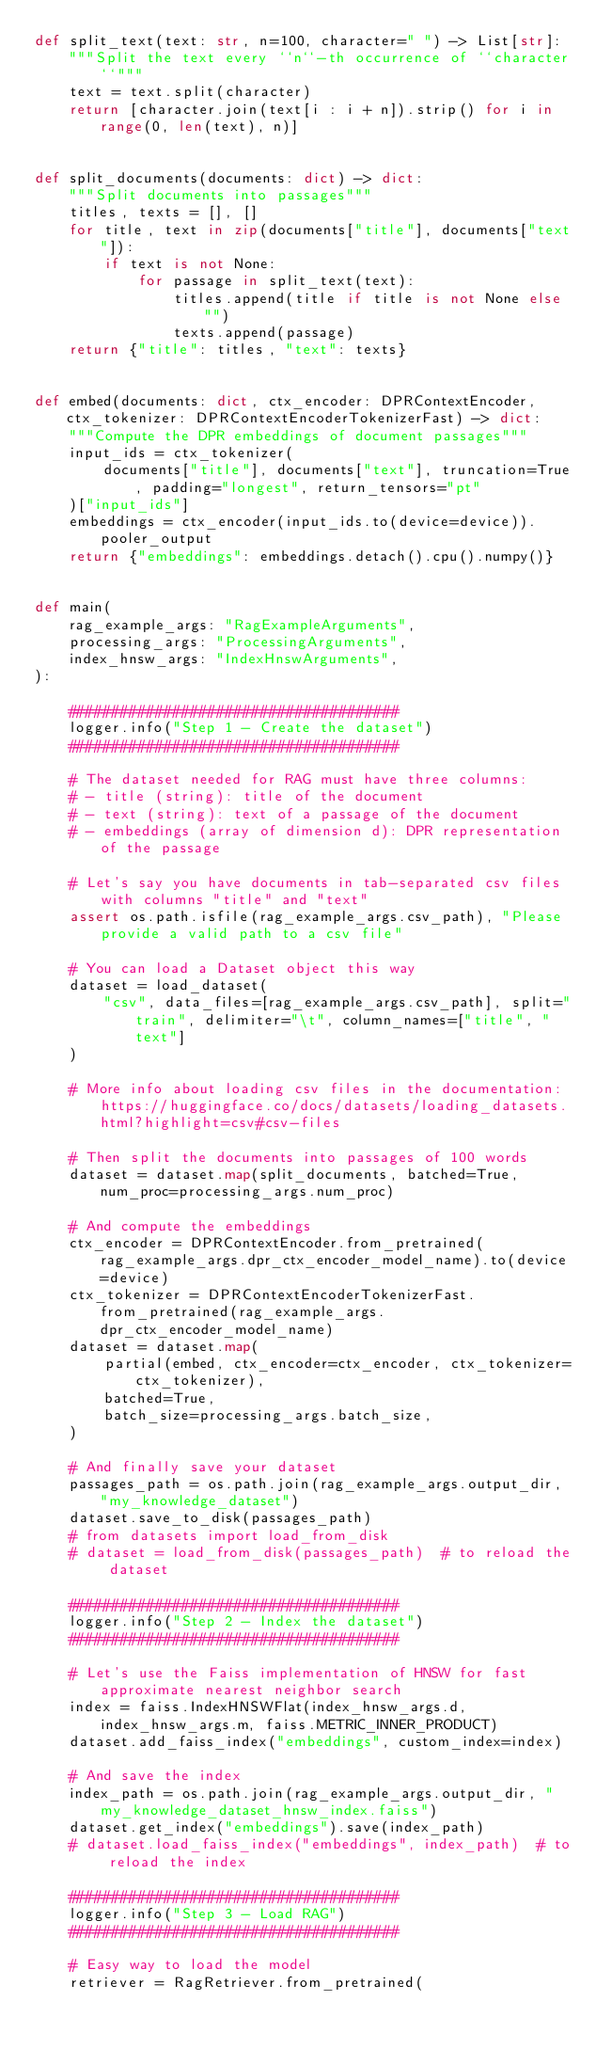<code> <loc_0><loc_0><loc_500><loc_500><_Python_>def split_text(text: str, n=100, character=" ") -> List[str]:
    """Split the text every ``n``-th occurrence of ``character``"""
    text = text.split(character)
    return [character.join(text[i : i + n]).strip() for i in range(0, len(text), n)]


def split_documents(documents: dict) -> dict:
    """Split documents into passages"""
    titles, texts = [], []
    for title, text in zip(documents["title"], documents["text"]):
        if text is not None:
            for passage in split_text(text):
                titles.append(title if title is not None else "")
                texts.append(passage)
    return {"title": titles, "text": texts}


def embed(documents: dict, ctx_encoder: DPRContextEncoder, ctx_tokenizer: DPRContextEncoderTokenizerFast) -> dict:
    """Compute the DPR embeddings of document passages"""
    input_ids = ctx_tokenizer(
        documents["title"], documents["text"], truncation=True, padding="longest", return_tensors="pt"
    )["input_ids"]
    embeddings = ctx_encoder(input_ids.to(device=device)).pooler_output
    return {"embeddings": embeddings.detach().cpu().numpy()}


def main(
    rag_example_args: "RagExampleArguments",
    processing_args: "ProcessingArguments",
    index_hnsw_args: "IndexHnswArguments",
):

    ######################################
    logger.info("Step 1 - Create the dataset")
    ######################################

    # The dataset needed for RAG must have three columns:
    # - title (string): title of the document
    # - text (string): text of a passage of the document
    # - embeddings (array of dimension d): DPR representation of the passage

    # Let's say you have documents in tab-separated csv files with columns "title" and "text"
    assert os.path.isfile(rag_example_args.csv_path), "Please provide a valid path to a csv file"

    # You can load a Dataset object this way
    dataset = load_dataset(
        "csv", data_files=[rag_example_args.csv_path], split="train", delimiter="\t", column_names=["title", "text"]
    )

    # More info about loading csv files in the documentation: https://huggingface.co/docs/datasets/loading_datasets.html?highlight=csv#csv-files

    # Then split the documents into passages of 100 words
    dataset = dataset.map(split_documents, batched=True, num_proc=processing_args.num_proc)

    # And compute the embeddings
    ctx_encoder = DPRContextEncoder.from_pretrained(rag_example_args.dpr_ctx_encoder_model_name).to(device=device)
    ctx_tokenizer = DPRContextEncoderTokenizerFast.from_pretrained(rag_example_args.dpr_ctx_encoder_model_name)
    dataset = dataset.map(
        partial(embed, ctx_encoder=ctx_encoder, ctx_tokenizer=ctx_tokenizer),
        batched=True,
        batch_size=processing_args.batch_size,
    )

    # And finally save your dataset
    passages_path = os.path.join(rag_example_args.output_dir, "my_knowledge_dataset")
    dataset.save_to_disk(passages_path)
    # from datasets import load_from_disk
    # dataset = load_from_disk(passages_path)  # to reload the dataset

    ######################################
    logger.info("Step 2 - Index the dataset")
    ######################################

    # Let's use the Faiss implementation of HNSW for fast approximate nearest neighbor search
    index = faiss.IndexHNSWFlat(index_hnsw_args.d, index_hnsw_args.m, faiss.METRIC_INNER_PRODUCT)
    dataset.add_faiss_index("embeddings", custom_index=index)

    # And save the index
    index_path = os.path.join(rag_example_args.output_dir, "my_knowledge_dataset_hnsw_index.faiss")
    dataset.get_index("embeddings").save(index_path)
    # dataset.load_faiss_index("embeddings", index_path)  # to reload the index

    ######################################
    logger.info("Step 3 - Load RAG")
    ######################################

    # Easy way to load the model
    retriever = RagRetriever.from_pretrained(</code> 